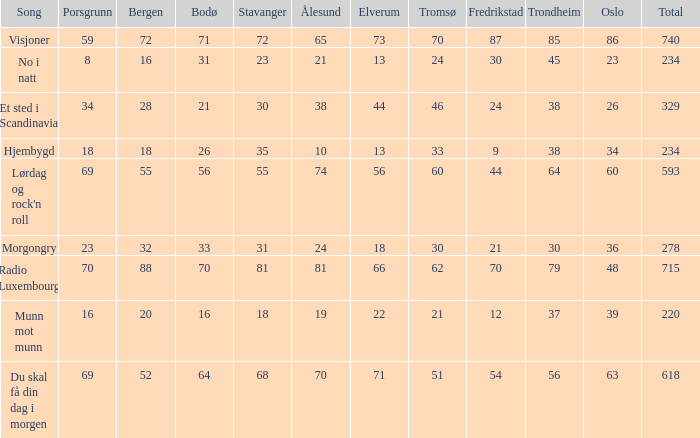When bergen reaches 88, what will be the alesund? 81.0. 